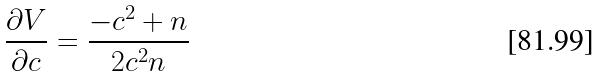<formula> <loc_0><loc_0><loc_500><loc_500>\frac { \partial V } { \partial c } = \frac { - c ^ { 2 } + n } { 2 c ^ { 2 } n }</formula> 